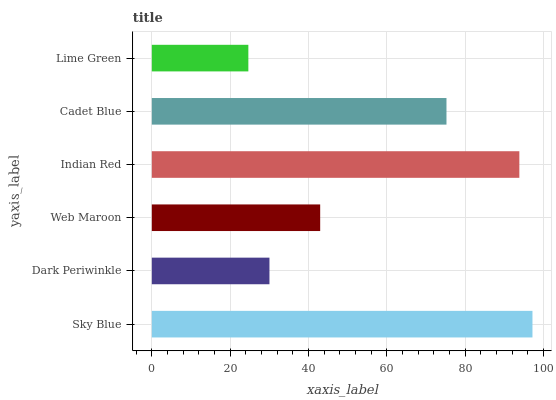Is Lime Green the minimum?
Answer yes or no. Yes. Is Sky Blue the maximum?
Answer yes or no. Yes. Is Dark Periwinkle the minimum?
Answer yes or no. No. Is Dark Periwinkle the maximum?
Answer yes or no. No. Is Sky Blue greater than Dark Periwinkle?
Answer yes or no. Yes. Is Dark Periwinkle less than Sky Blue?
Answer yes or no. Yes. Is Dark Periwinkle greater than Sky Blue?
Answer yes or no. No. Is Sky Blue less than Dark Periwinkle?
Answer yes or no. No. Is Cadet Blue the high median?
Answer yes or no. Yes. Is Web Maroon the low median?
Answer yes or no. Yes. Is Dark Periwinkle the high median?
Answer yes or no. No. Is Cadet Blue the low median?
Answer yes or no. No. 